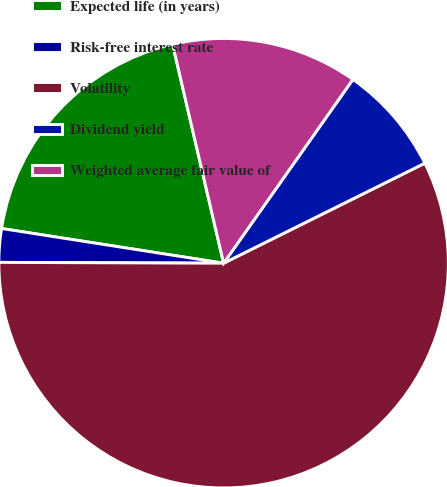Convert chart to OTSL. <chart><loc_0><loc_0><loc_500><loc_500><pie_chart><fcel>Expected life (in years)<fcel>Risk-free interest rate<fcel>Volatility<fcel>Dividend yield<fcel>Weighted average fair value of<nl><fcel>18.89%<fcel>2.41%<fcel>57.4%<fcel>7.9%<fcel>13.4%<nl></chart> 